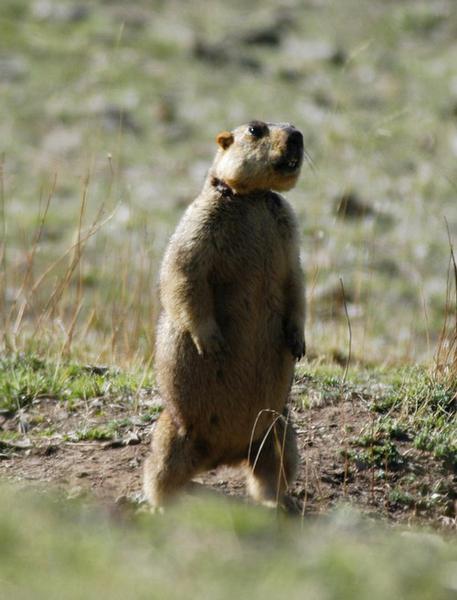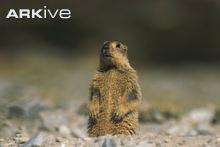The first image is the image on the left, the second image is the image on the right. Assess this claim about the two images: "The right image contains at least two rodents.". Correct or not? Answer yes or no. No. The first image is the image on the left, the second image is the image on the right. Considering the images on both sides, is "We've got three groundhogs here." valid? Answer yes or no. No. 